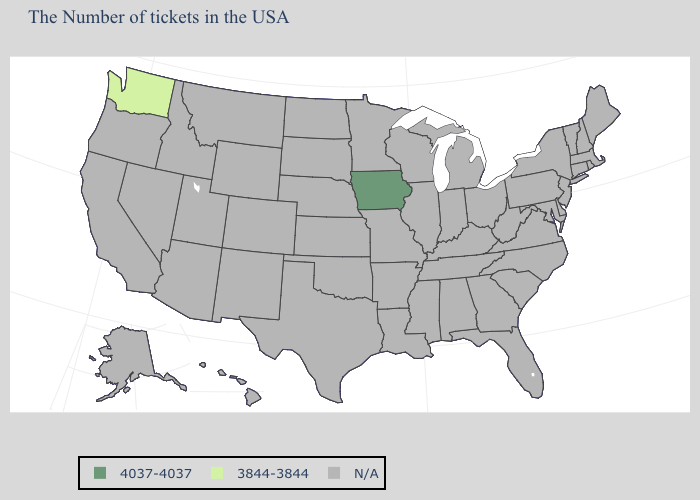What is the lowest value in states that border Oregon?
Answer briefly. 3844-3844. Which states hav the highest value in the West?
Concise answer only. Washington. What is the lowest value in the MidWest?
Be succinct. 4037-4037. What is the value of South Dakota?
Write a very short answer. N/A. What is the lowest value in the USA?
Write a very short answer. 3844-3844. What is the value of New Mexico?
Be succinct. N/A. What is the lowest value in the MidWest?
Write a very short answer. 4037-4037. Name the states that have a value in the range 3844-3844?
Concise answer only. Washington. Does the map have missing data?
Short answer required. Yes. How many symbols are there in the legend?
Concise answer only. 3. 